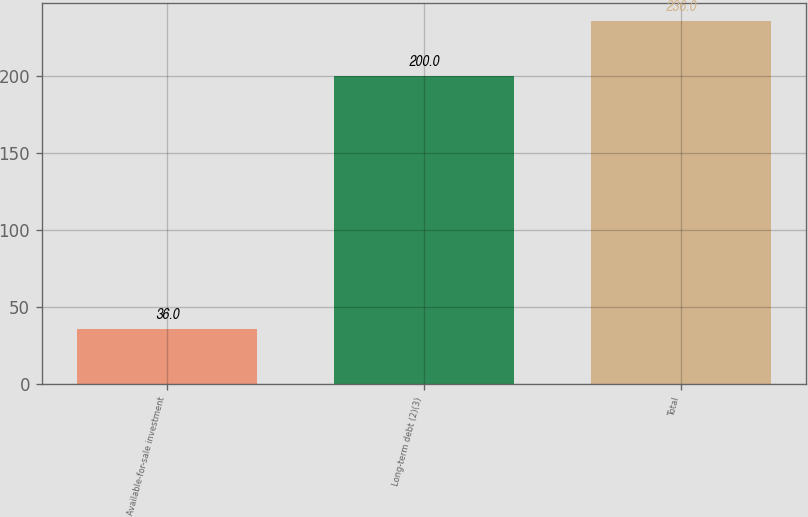Convert chart to OTSL. <chart><loc_0><loc_0><loc_500><loc_500><bar_chart><fcel>Available-for-sale investment<fcel>Long-term debt (2)(3)<fcel>Total<nl><fcel>36<fcel>200<fcel>236<nl></chart> 